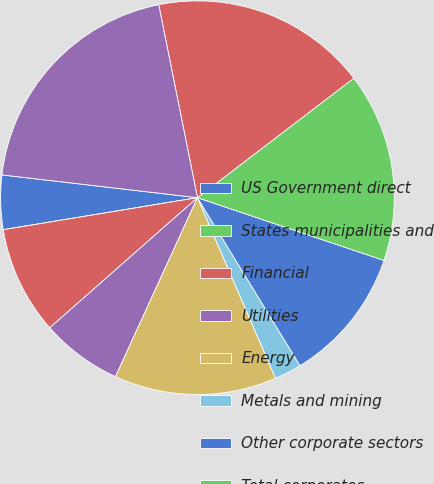<chart> <loc_0><loc_0><loc_500><loc_500><pie_chart><fcel>US Government direct<fcel>States municipalities and<fcel>Financial<fcel>Utilities<fcel>Energy<fcel>Metals and mining<fcel>Other corporate sectors<fcel>Total corporates<fcel>Total investment grade<fcel>Total below investment grade<nl><fcel>4.45%<fcel>0.0%<fcel>8.89%<fcel>6.67%<fcel>13.33%<fcel>2.23%<fcel>11.11%<fcel>15.55%<fcel>17.77%<fcel>20.0%<nl></chart> 